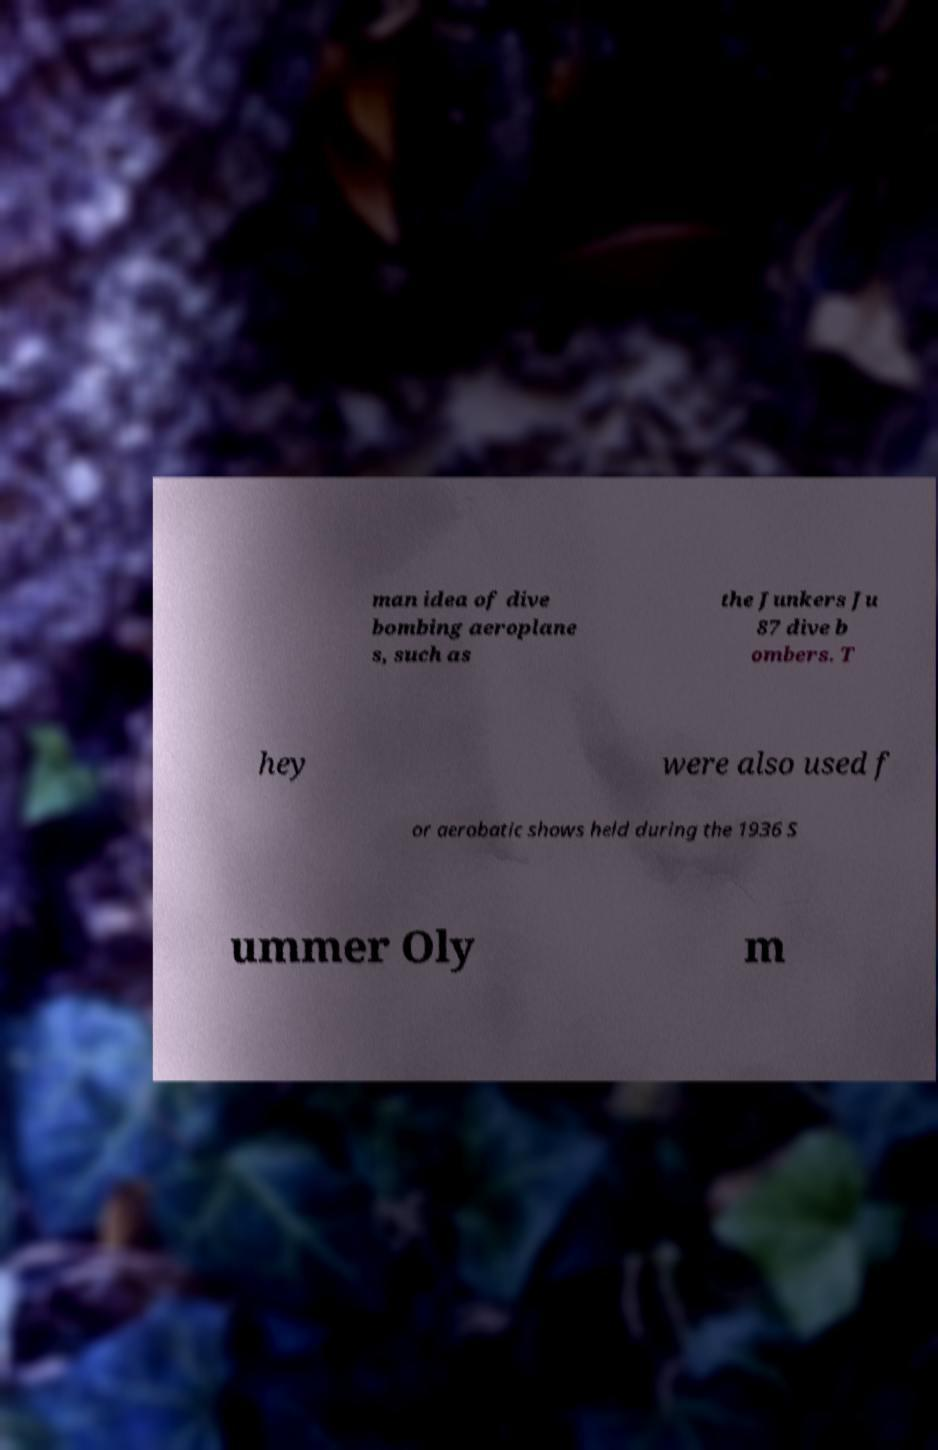Can you accurately transcribe the text from the provided image for me? man idea of dive bombing aeroplane s, such as the Junkers Ju 87 dive b ombers. T hey were also used f or aerobatic shows held during the 1936 S ummer Oly m 